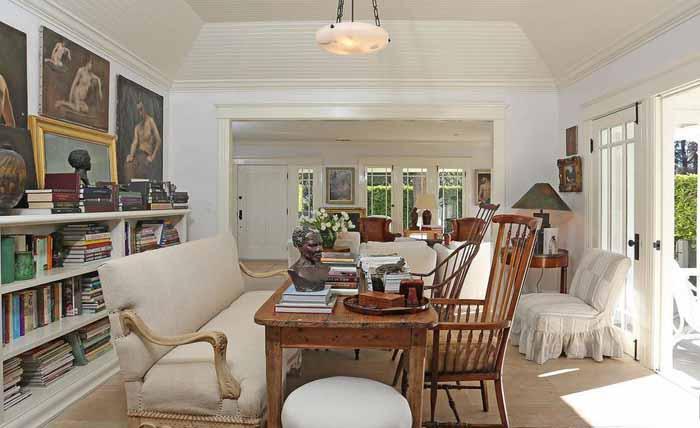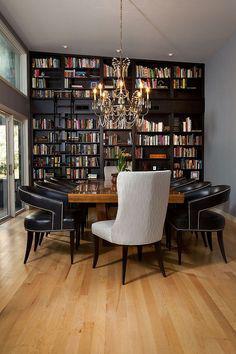The first image is the image on the left, the second image is the image on the right. Assess this claim about the two images: "In one image, a round dining table with chairs and centerpiece is located near large bookshelves.". Correct or not? Answer yes or no. No. 